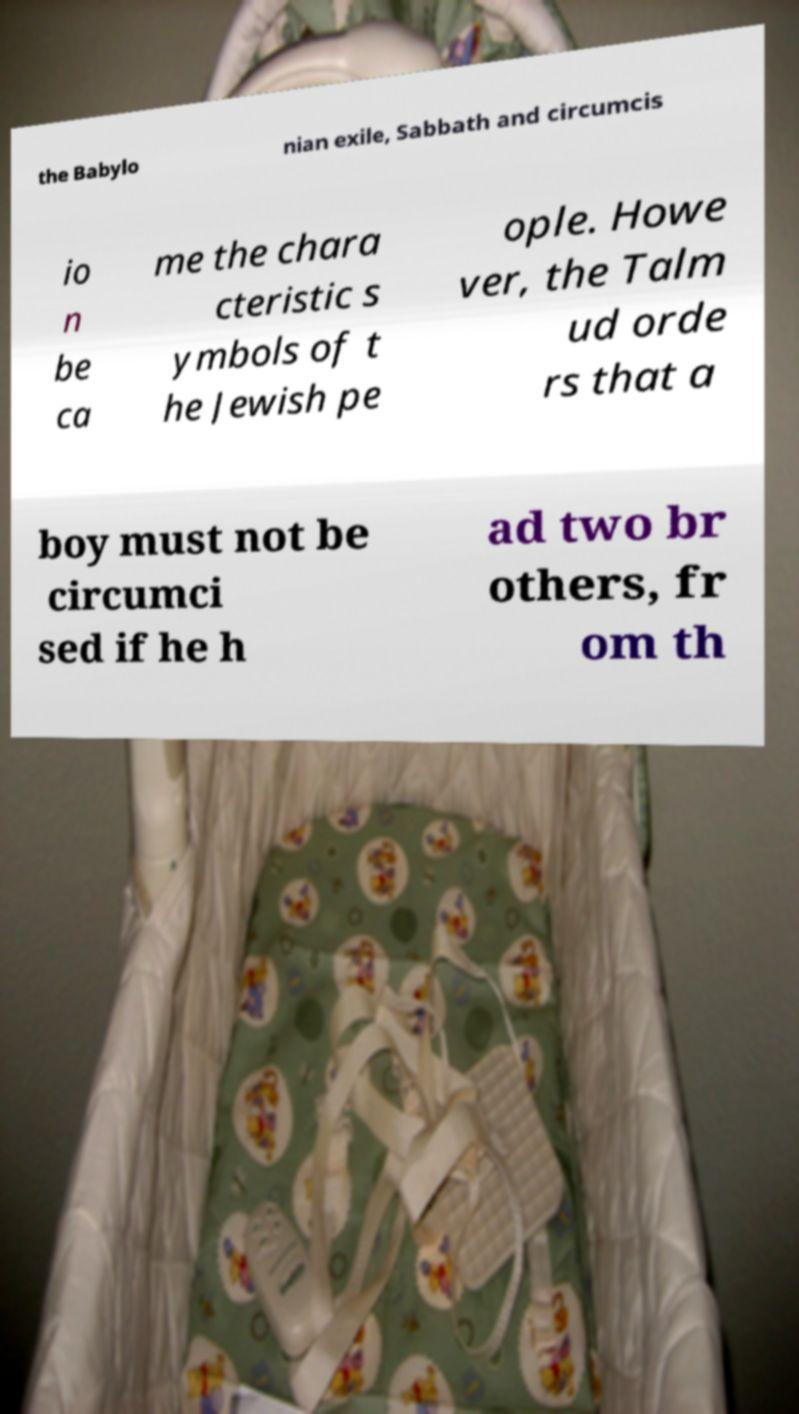Can you accurately transcribe the text from the provided image for me? the Babylo nian exile, Sabbath and circumcis io n be ca me the chara cteristic s ymbols of t he Jewish pe ople. Howe ver, the Talm ud orde rs that a boy must not be circumci sed if he h ad two br others, fr om th 